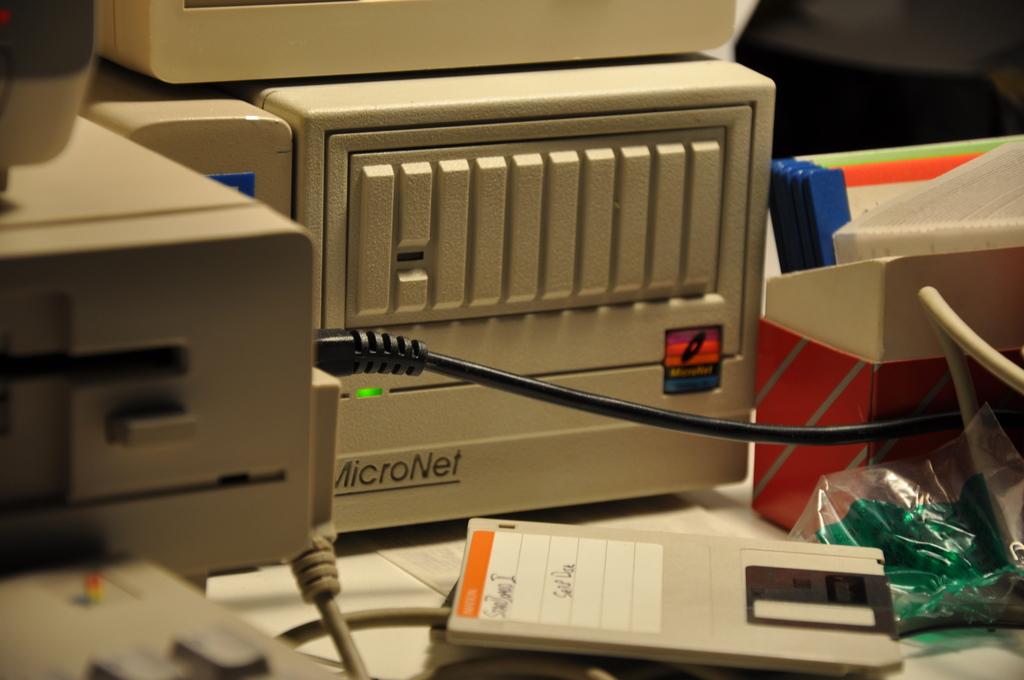What brand of cpu is the green light on?
Your answer should be compact. Micronet. 